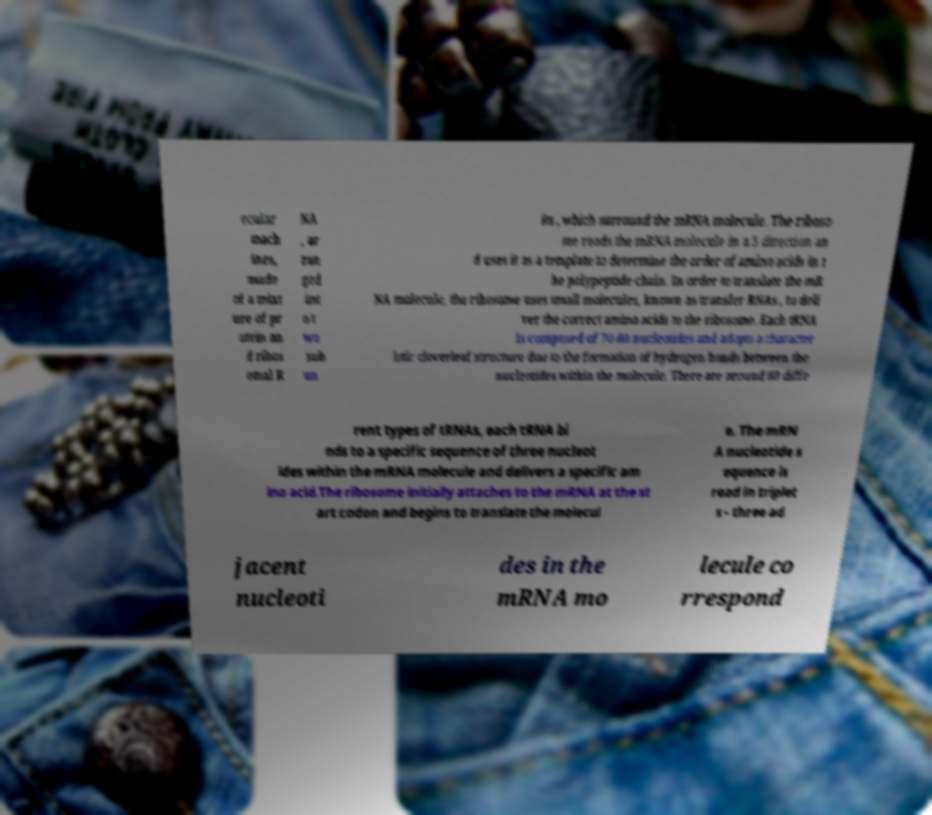Please identify and transcribe the text found in this image. ecular mach ines, made of a mixt ure of pr otein an d ribos omal R NA , ar ran ged int o t wo sub un its , which surround the mRNA molecule. The riboso me reads the mRNA molecule in a 5 direction an d uses it as a template to determine the order of amino acids in t he polypeptide chain. In order to translate the mR NA molecule, the ribosome uses small molecules, known as transfer RNAs , to deli ver the correct amino acids to the ribosome. Each tRNA is composed of 70-80 nucleotides and adopts a character istic cloverleaf structure due to the formation of hydrogen bonds between the nucleotides within the molecule. There are around 60 diffe rent types of tRNAs, each tRNA bi nds to a specific sequence of three nucleot ides within the mRNA molecule and delivers a specific am ino acid.The ribosome initially attaches to the mRNA at the st art codon and begins to translate the molecul e. The mRN A nucleotide s equence is read in triplet s - three ad jacent nucleoti des in the mRNA mo lecule co rrespond 